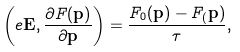<formula> <loc_0><loc_0><loc_500><loc_500>\left ( e \mathbf E , \frac { \partial F ( \mathbf p ) } { \partial \mathbf p } \right ) = \frac { F _ { 0 } ( \mathbf p ) - F _ { ( } \mathbf p ) } { \tau } ,</formula> 